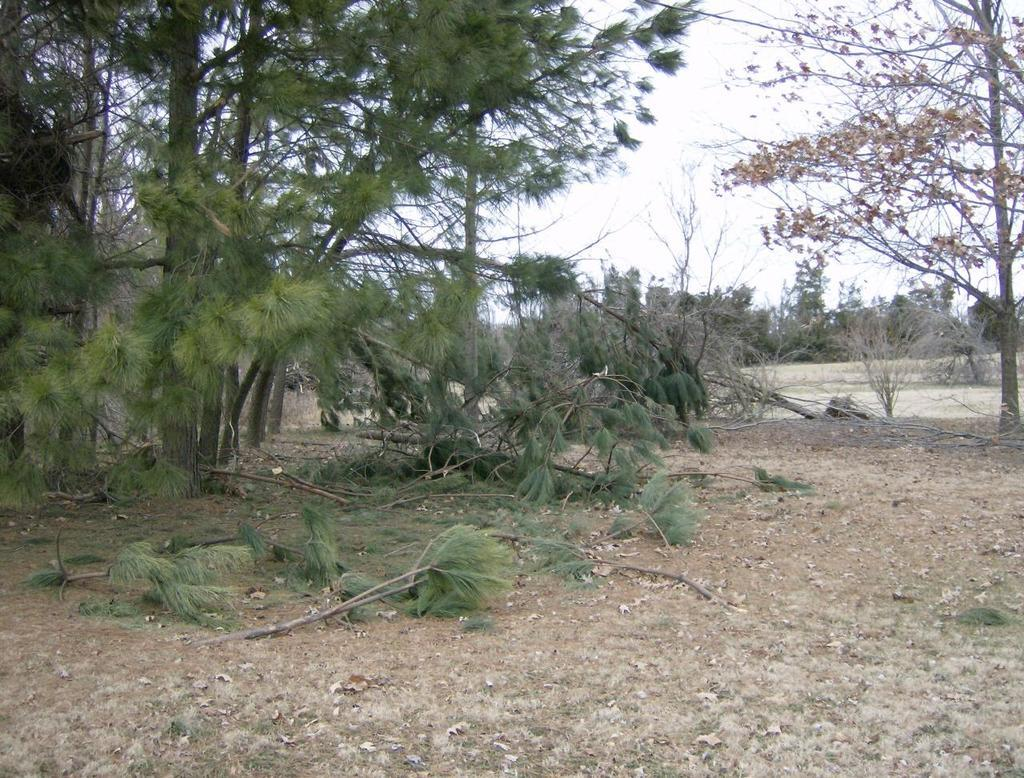What can be seen in the sky in the image? The sky is visible in the image. What type of vegetation is present in the image? There are trees in the image, including dried trees. What is present on the ground in the image? Dried leaves and branches are present on the ground in the image. What type of property is for sale in the image? There is no property for sale in the image; it primarily features trees and the sky. How much money is visible in the image? There is no money present in the image. Can you see any chickens in the image? There are no chickens present in the image. 